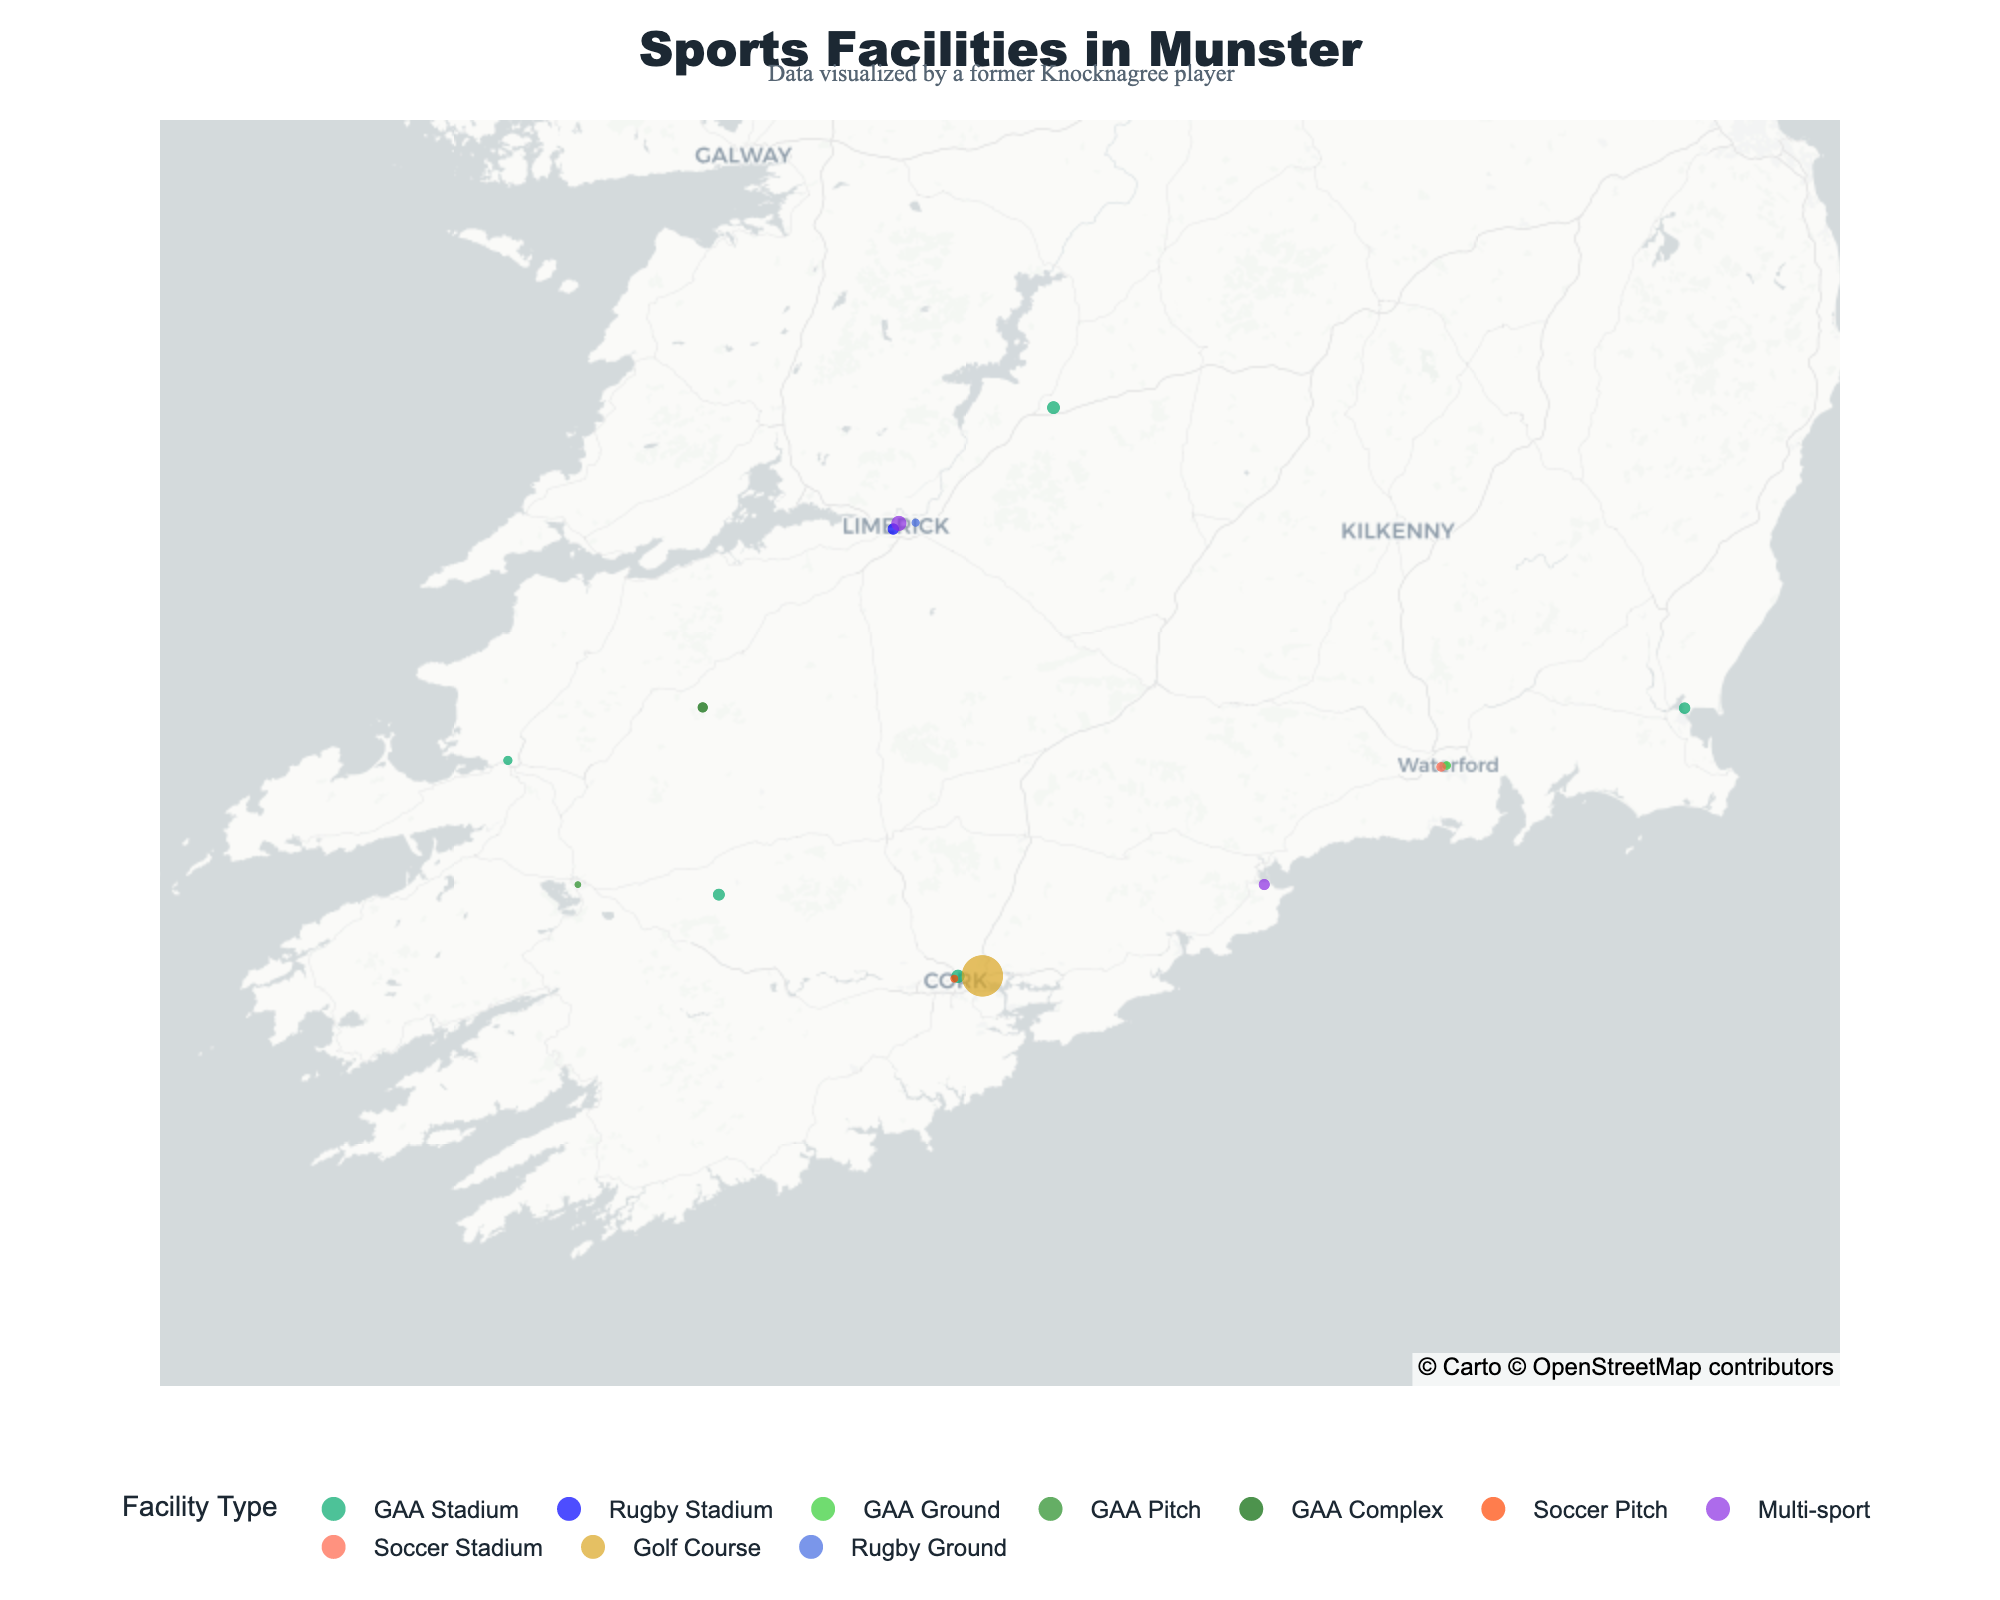How many GAA Stadiums are there in Munster? By examining the map and the color code for 'GAA Stadium', we can count the number of such facilities.
Answer: 5 Which facility is the largest in terms of size? By checking the size indicated for each facility, the largest is Mahon Golf Course with 45.0 hectares.
Answer: Mahon Golf Course What type of sports facility is most densely located in County Cork? Count the number of each type of facility in County Cork. The most common type in Cork is 'GAA Stadium' with multiple entries.
Answer: GAA Stadium Which facility in Kerry has the smallest size? Compare the sizes of facilities in Kerry; Austin Stack Park at 2.6 hectares is the smallest.
Answer: Austin Stack Park What is the total size of all soccer-related facilities? Sum the size of each facility categorized as 'Soccer Pitch' or 'Soccer Stadium'. They are 2.0 and 2.8 hectares respectively. 2.0 + 2.8 = 4.8 hectares.
Answer: 4.8 hectares How many multi-sport facilities are displayed on the map? Count the number of facilities labeled as 'Multi-sport' which includes University of Limerick Sport Arena and Dungarvan Sports Centre.
Answer: 2 What is the difference in size between Fitzgerald Stadium and Thomond Park? Subtract the size of Thomond Park from Fitzgerald Stadium: 4.2 - 3.8 = 0.4 hectares.
Answer: 0.4 hectares Which county has a higher number of facilities, Limerick or Waterford? Count the number of facilities in Limerick (3) and in Waterford (3). Both counties have the same number.
Answer: Both have the same How far is Knocknagree GAA Grounds from the nearest sports facility? Observe the map, the closest nearby point to Knocknagree GAA Grounds is John Mitchels GAA Complex.
Answer: John Mitchels GAA Complex 